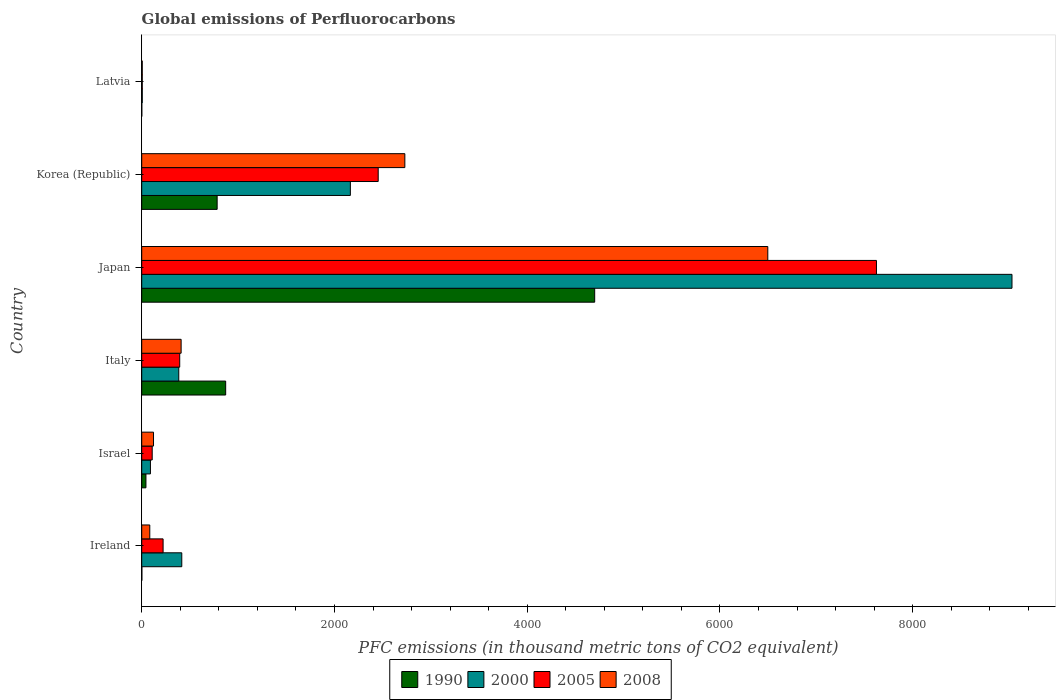How many different coloured bars are there?
Provide a succinct answer. 4. Are the number of bars on each tick of the Y-axis equal?
Make the answer very short. Yes. How many bars are there on the 2nd tick from the top?
Your response must be concise. 4. How many bars are there on the 4th tick from the bottom?
Offer a very short reply. 4. What is the label of the 3rd group of bars from the top?
Your response must be concise. Japan. What is the global emissions of Perfluorocarbons in 2005 in Italy?
Provide a succinct answer. 394.3. Across all countries, what is the maximum global emissions of Perfluorocarbons in 2008?
Give a very brief answer. 6496.1. In which country was the global emissions of Perfluorocarbons in 2005 maximum?
Give a very brief answer. Japan. In which country was the global emissions of Perfluorocarbons in 2000 minimum?
Provide a short and direct response. Latvia. What is the total global emissions of Perfluorocarbons in 2005 in the graph?
Offer a terse response. 1.08e+04. What is the difference between the global emissions of Perfluorocarbons in 2008 in Ireland and that in Korea (Republic)?
Ensure brevity in your answer.  -2646.5. What is the difference between the global emissions of Perfluorocarbons in 2000 in Italy and the global emissions of Perfluorocarbons in 2008 in Israel?
Offer a terse response. 262. What is the average global emissions of Perfluorocarbons in 2005 per country?
Keep it short and to the point. 1801.27. What is the ratio of the global emissions of Perfluorocarbons in 2008 in Ireland to that in Italy?
Provide a short and direct response. 0.2. Is the global emissions of Perfluorocarbons in 2005 in Ireland less than that in Israel?
Offer a very short reply. No. What is the difference between the highest and the second highest global emissions of Perfluorocarbons in 2008?
Offer a very short reply. 3766. What is the difference between the highest and the lowest global emissions of Perfluorocarbons in 2008?
Make the answer very short. 6490.6. Is the sum of the global emissions of Perfluorocarbons in 2008 in Israel and Korea (Republic) greater than the maximum global emissions of Perfluorocarbons in 2005 across all countries?
Your response must be concise. No. Is it the case that in every country, the sum of the global emissions of Perfluorocarbons in 2000 and global emissions of Perfluorocarbons in 2008 is greater than the sum of global emissions of Perfluorocarbons in 1990 and global emissions of Perfluorocarbons in 2005?
Make the answer very short. No. What does the 2nd bar from the top in Ireland represents?
Offer a very short reply. 2005. Is it the case that in every country, the sum of the global emissions of Perfluorocarbons in 2000 and global emissions of Perfluorocarbons in 2008 is greater than the global emissions of Perfluorocarbons in 2005?
Provide a succinct answer. Yes. What is the difference between two consecutive major ticks on the X-axis?
Provide a succinct answer. 2000. Are the values on the major ticks of X-axis written in scientific E-notation?
Your response must be concise. No. Does the graph contain grids?
Your response must be concise. No. How are the legend labels stacked?
Keep it short and to the point. Horizontal. What is the title of the graph?
Keep it short and to the point. Global emissions of Perfluorocarbons. What is the label or title of the X-axis?
Ensure brevity in your answer.  PFC emissions (in thousand metric tons of CO2 equivalent). What is the label or title of the Y-axis?
Give a very brief answer. Country. What is the PFC emissions (in thousand metric tons of CO2 equivalent) of 1990 in Ireland?
Provide a short and direct response. 1.4. What is the PFC emissions (in thousand metric tons of CO2 equivalent) in 2000 in Ireland?
Give a very brief answer. 415.6. What is the PFC emissions (in thousand metric tons of CO2 equivalent) of 2005 in Ireland?
Offer a very short reply. 221.8. What is the PFC emissions (in thousand metric tons of CO2 equivalent) in 2008 in Ireland?
Ensure brevity in your answer.  83.6. What is the PFC emissions (in thousand metric tons of CO2 equivalent) of 1990 in Israel?
Make the answer very short. 43.8. What is the PFC emissions (in thousand metric tons of CO2 equivalent) of 2000 in Israel?
Keep it short and to the point. 90.5. What is the PFC emissions (in thousand metric tons of CO2 equivalent) in 2005 in Israel?
Ensure brevity in your answer.  108.7. What is the PFC emissions (in thousand metric tons of CO2 equivalent) of 2008 in Israel?
Your answer should be compact. 122.3. What is the PFC emissions (in thousand metric tons of CO2 equivalent) in 1990 in Italy?
Your response must be concise. 871. What is the PFC emissions (in thousand metric tons of CO2 equivalent) in 2000 in Italy?
Keep it short and to the point. 384.3. What is the PFC emissions (in thousand metric tons of CO2 equivalent) of 2005 in Italy?
Ensure brevity in your answer.  394.3. What is the PFC emissions (in thousand metric tons of CO2 equivalent) of 2008 in Italy?
Your answer should be compact. 408.8. What is the PFC emissions (in thousand metric tons of CO2 equivalent) in 1990 in Japan?
Offer a very short reply. 4700. What is the PFC emissions (in thousand metric tons of CO2 equivalent) in 2000 in Japan?
Offer a terse response. 9029.8. What is the PFC emissions (in thousand metric tons of CO2 equivalent) in 2005 in Japan?
Provide a short and direct response. 7623.6. What is the PFC emissions (in thousand metric tons of CO2 equivalent) in 2008 in Japan?
Give a very brief answer. 6496.1. What is the PFC emissions (in thousand metric tons of CO2 equivalent) of 1990 in Korea (Republic)?
Provide a short and direct response. 782.6. What is the PFC emissions (in thousand metric tons of CO2 equivalent) in 2000 in Korea (Republic)?
Provide a short and direct response. 2164.9. What is the PFC emissions (in thousand metric tons of CO2 equivalent) of 2005 in Korea (Republic)?
Your answer should be compact. 2453.7. What is the PFC emissions (in thousand metric tons of CO2 equivalent) of 2008 in Korea (Republic)?
Your answer should be compact. 2730.1. What is the PFC emissions (in thousand metric tons of CO2 equivalent) of 2000 in Latvia?
Keep it short and to the point. 5.7. Across all countries, what is the maximum PFC emissions (in thousand metric tons of CO2 equivalent) of 1990?
Your answer should be very brief. 4700. Across all countries, what is the maximum PFC emissions (in thousand metric tons of CO2 equivalent) of 2000?
Your answer should be compact. 9029.8. Across all countries, what is the maximum PFC emissions (in thousand metric tons of CO2 equivalent) in 2005?
Provide a succinct answer. 7623.6. Across all countries, what is the maximum PFC emissions (in thousand metric tons of CO2 equivalent) in 2008?
Provide a short and direct response. 6496.1. Across all countries, what is the minimum PFC emissions (in thousand metric tons of CO2 equivalent) of 2005?
Your answer should be very brief. 5.5. What is the total PFC emissions (in thousand metric tons of CO2 equivalent) in 1990 in the graph?
Provide a succinct answer. 6399.5. What is the total PFC emissions (in thousand metric tons of CO2 equivalent) in 2000 in the graph?
Your response must be concise. 1.21e+04. What is the total PFC emissions (in thousand metric tons of CO2 equivalent) of 2005 in the graph?
Ensure brevity in your answer.  1.08e+04. What is the total PFC emissions (in thousand metric tons of CO2 equivalent) of 2008 in the graph?
Make the answer very short. 9846.4. What is the difference between the PFC emissions (in thousand metric tons of CO2 equivalent) in 1990 in Ireland and that in Israel?
Provide a short and direct response. -42.4. What is the difference between the PFC emissions (in thousand metric tons of CO2 equivalent) of 2000 in Ireland and that in Israel?
Your response must be concise. 325.1. What is the difference between the PFC emissions (in thousand metric tons of CO2 equivalent) of 2005 in Ireland and that in Israel?
Your response must be concise. 113.1. What is the difference between the PFC emissions (in thousand metric tons of CO2 equivalent) in 2008 in Ireland and that in Israel?
Your response must be concise. -38.7. What is the difference between the PFC emissions (in thousand metric tons of CO2 equivalent) in 1990 in Ireland and that in Italy?
Your answer should be compact. -869.6. What is the difference between the PFC emissions (in thousand metric tons of CO2 equivalent) of 2000 in Ireland and that in Italy?
Provide a short and direct response. 31.3. What is the difference between the PFC emissions (in thousand metric tons of CO2 equivalent) of 2005 in Ireland and that in Italy?
Your answer should be compact. -172.5. What is the difference between the PFC emissions (in thousand metric tons of CO2 equivalent) in 2008 in Ireland and that in Italy?
Provide a succinct answer. -325.2. What is the difference between the PFC emissions (in thousand metric tons of CO2 equivalent) of 1990 in Ireland and that in Japan?
Your answer should be compact. -4698.6. What is the difference between the PFC emissions (in thousand metric tons of CO2 equivalent) in 2000 in Ireland and that in Japan?
Offer a very short reply. -8614.2. What is the difference between the PFC emissions (in thousand metric tons of CO2 equivalent) in 2005 in Ireland and that in Japan?
Your response must be concise. -7401.8. What is the difference between the PFC emissions (in thousand metric tons of CO2 equivalent) in 2008 in Ireland and that in Japan?
Keep it short and to the point. -6412.5. What is the difference between the PFC emissions (in thousand metric tons of CO2 equivalent) in 1990 in Ireland and that in Korea (Republic)?
Give a very brief answer. -781.2. What is the difference between the PFC emissions (in thousand metric tons of CO2 equivalent) of 2000 in Ireland and that in Korea (Republic)?
Your answer should be compact. -1749.3. What is the difference between the PFC emissions (in thousand metric tons of CO2 equivalent) of 2005 in Ireland and that in Korea (Republic)?
Provide a short and direct response. -2231.9. What is the difference between the PFC emissions (in thousand metric tons of CO2 equivalent) in 2008 in Ireland and that in Korea (Republic)?
Provide a succinct answer. -2646.5. What is the difference between the PFC emissions (in thousand metric tons of CO2 equivalent) in 1990 in Ireland and that in Latvia?
Ensure brevity in your answer.  0.7. What is the difference between the PFC emissions (in thousand metric tons of CO2 equivalent) of 2000 in Ireland and that in Latvia?
Keep it short and to the point. 409.9. What is the difference between the PFC emissions (in thousand metric tons of CO2 equivalent) of 2005 in Ireland and that in Latvia?
Your answer should be compact. 216.3. What is the difference between the PFC emissions (in thousand metric tons of CO2 equivalent) of 2008 in Ireland and that in Latvia?
Give a very brief answer. 78.1. What is the difference between the PFC emissions (in thousand metric tons of CO2 equivalent) of 1990 in Israel and that in Italy?
Make the answer very short. -827.2. What is the difference between the PFC emissions (in thousand metric tons of CO2 equivalent) of 2000 in Israel and that in Italy?
Make the answer very short. -293.8. What is the difference between the PFC emissions (in thousand metric tons of CO2 equivalent) of 2005 in Israel and that in Italy?
Give a very brief answer. -285.6. What is the difference between the PFC emissions (in thousand metric tons of CO2 equivalent) of 2008 in Israel and that in Italy?
Offer a very short reply. -286.5. What is the difference between the PFC emissions (in thousand metric tons of CO2 equivalent) in 1990 in Israel and that in Japan?
Offer a very short reply. -4656.2. What is the difference between the PFC emissions (in thousand metric tons of CO2 equivalent) in 2000 in Israel and that in Japan?
Provide a short and direct response. -8939.3. What is the difference between the PFC emissions (in thousand metric tons of CO2 equivalent) of 2005 in Israel and that in Japan?
Your answer should be compact. -7514.9. What is the difference between the PFC emissions (in thousand metric tons of CO2 equivalent) in 2008 in Israel and that in Japan?
Provide a succinct answer. -6373.8. What is the difference between the PFC emissions (in thousand metric tons of CO2 equivalent) in 1990 in Israel and that in Korea (Republic)?
Your response must be concise. -738.8. What is the difference between the PFC emissions (in thousand metric tons of CO2 equivalent) of 2000 in Israel and that in Korea (Republic)?
Ensure brevity in your answer.  -2074.4. What is the difference between the PFC emissions (in thousand metric tons of CO2 equivalent) of 2005 in Israel and that in Korea (Republic)?
Offer a very short reply. -2345. What is the difference between the PFC emissions (in thousand metric tons of CO2 equivalent) in 2008 in Israel and that in Korea (Republic)?
Provide a succinct answer. -2607.8. What is the difference between the PFC emissions (in thousand metric tons of CO2 equivalent) in 1990 in Israel and that in Latvia?
Keep it short and to the point. 43.1. What is the difference between the PFC emissions (in thousand metric tons of CO2 equivalent) of 2000 in Israel and that in Latvia?
Your answer should be very brief. 84.8. What is the difference between the PFC emissions (in thousand metric tons of CO2 equivalent) of 2005 in Israel and that in Latvia?
Your answer should be very brief. 103.2. What is the difference between the PFC emissions (in thousand metric tons of CO2 equivalent) in 2008 in Israel and that in Latvia?
Make the answer very short. 116.8. What is the difference between the PFC emissions (in thousand metric tons of CO2 equivalent) in 1990 in Italy and that in Japan?
Give a very brief answer. -3829. What is the difference between the PFC emissions (in thousand metric tons of CO2 equivalent) in 2000 in Italy and that in Japan?
Your answer should be compact. -8645.5. What is the difference between the PFC emissions (in thousand metric tons of CO2 equivalent) in 2005 in Italy and that in Japan?
Provide a succinct answer. -7229.3. What is the difference between the PFC emissions (in thousand metric tons of CO2 equivalent) in 2008 in Italy and that in Japan?
Your response must be concise. -6087.3. What is the difference between the PFC emissions (in thousand metric tons of CO2 equivalent) of 1990 in Italy and that in Korea (Republic)?
Your response must be concise. 88.4. What is the difference between the PFC emissions (in thousand metric tons of CO2 equivalent) in 2000 in Italy and that in Korea (Republic)?
Ensure brevity in your answer.  -1780.6. What is the difference between the PFC emissions (in thousand metric tons of CO2 equivalent) in 2005 in Italy and that in Korea (Republic)?
Your answer should be compact. -2059.4. What is the difference between the PFC emissions (in thousand metric tons of CO2 equivalent) of 2008 in Italy and that in Korea (Republic)?
Give a very brief answer. -2321.3. What is the difference between the PFC emissions (in thousand metric tons of CO2 equivalent) of 1990 in Italy and that in Latvia?
Offer a terse response. 870.3. What is the difference between the PFC emissions (in thousand metric tons of CO2 equivalent) in 2000 in Italy and that in Latvia?
Provide a short and direct response. 378.6. What is the difference between the PFC emissions (in thousand metric tons of CO2 equivalent) in 2005 in Italy and that in Latvia?
Your answer should be compact. 388.8. What is the difference between the PFC emissions (in thousand metric tons of CO2 equivalent) of 2008 in Italy and that in Latvia?
Give a very brief answer. 403.3. What is the difference between the PFC emissions (in thousand metric tons of CO2 equivalent) of 1990 in Japan and that in Korea (Republic)?
Your response must be concise. 3917.4. What is the difference between the PFC emissions (in thousand metric tons of CO2 equivalent) in 2000 in Japan and that in Korea (Republic)?
Provide a succinct answer. 6864.9. What is the difference between the PFC emissions (in thousand metric tons of CO2 equivalent) in 2005 in Japan and that in Korea (Republic)?
Make the answer very short. 5169.9. What is the difference between the PFC emissions (in thousand metric tons of CO2 equivalent) of 2008 in Japan and that in Korea (Republic)?
Offer a terse response. 3766. What is the difference between the PFC emissions (in thousand metric tons of CO2 equivalent) in 1990 in Japan and that in Latvia?
Ensure brevity in your answer.  4699.3. What is the difference between the PFC emissions (in thousand metric tons of CO2 equivalent) in 2000 in Japan and that in Latvia?
Your answer should be very brief. 9024.1. What is the difference between the PFC emissions (in thousand metric tons of CO2 equivalent) of 2005 in Japan and that in Latvia?
Keep it short and to the point. 7618.1. What is the difference between the PFC emissions (in thousand metric tons of CO2 equivalent) in 2008 in Japan and that in Latvia?
Give a very brief answer. 6490.6. What is the difference between the PFC emissions (in thousand metric tons of CO2 equivalent) of 1990 in Korea (Republic) and that in Latvia?
Your response must be concise. 781.9. What is the difference between the PFC emissions (in thousand metric tons of CO2 equivalent) of 2000 in Korea (Republic) and that in Latvia?
Give a very brief answer. 2159.2. What is the difference between the PFC emissions (in thousand metric tons of CO2 equivalent) of 2005 in Korea (Republic) and that in Latvia?
Keep it short and to the point. 2448.2. What is the difference between the PFC emissions (in thousand metric tons of CO2 equivalent) of 2008 in Korea (Republic) and that in Latvia?
Offer a very short reply. 2724.6. What is the difference between the PFC emissions (in thousand metric tons of CO2 equivalent) of 1990 in Ireland and the PFC emissions (in thousand metric tons of CO2 equivalent) of 2000 in Israel?
Give a very brief answer. -89.1. What is the difference between the PFC emissions (in thousand metric tons of CO2 equivalent) in 1990 in Ireland and the PFC emissions (in thousand metric tons of CO2 equivalent) in 2005 in Israel?
Make the answer very short. -107.3. What is the difference between the PFC emissions (in thousand metric tons of CO2 equivalent) of 1990 in Ireland and the PFC emissions (in thousand metric tons of CO2 equivalent) of 2008 in Israel?
Offer a very short reply. -120.9. What is the difference between the PFC emissions (in thousand metric tons of CO2 equivalent) in 2000 in Ireland and the PFC emissions (in thousand metric tons of CO2 equivalent) in 2005 in Israel?
Your answer should be compact. 306.9. What is the difference between the PFC emissions (in thousand metric tons of CO2 equivalent) of 2000 in Ireland and the PFC emissions (in thousand metric tons of CO2 equivalent) of 2008 in Israel?
Your answer should be very brief. 293.3. What is the difference between the PFC emissions (in thousand metric tons of CO2 equivalent) in 2005 in Ireland and the PFC emissions (in thousand metric tons of CO2 equivalent) in 2008 in Israel?
Your answer should be compact. 99.5. What is the difference between the PFC emissions (in thousand metric tons of CO2 equivalent) of 1990 in Ireland and the PFC emissions (in thousand metric tons of CO2 equivalent) of 2000 in Italy?
Give a very brief answer. -382.9. What is the difference between the PFC emissions (in thousand metric tons of CO2 equivalent) in 1990 in Ireland and the PFC emissions (in thousand metric tons of CO2 equivalent) in 2005 in Italy?
Your answer should be very brief. -392.9. What is the difference between the PFC emissions (in thousand metric tons of CO2 equivalent) in 1990 in Ireland and the PFC emissions (in thousand metric tons of CO2 equivalent) in 2008 in Italy?
Give a very brief answer. -407.4. What is the difference between the PFC emissions (in thousand metric tons of CO2 equivalent) of 2000 in Ireland and the PFC emissions (in thousand metric tons of CO2 equivalent) of 2005 in Italy?
Provide a short and direct response. 21.3. What is the difference between the PFC emissions (in thousand metric tons of CO2 equivalent) in 2005 in Ireland and the PFC emissions (in thousand metric tons of CO2 equivalent) in 2008 in Italy?
Offer a terse response. -187. What is the difference between the PFC emissions (in thousand metric tons of CO2 equivalent) of 1990 in Ireland and the PFC emissions (in thousand metric tons of CO2 equivalent) of 2000 in Japan?
Provide a succinct answer. -9028.4. What is the difference between the PFC emissions (in thousand metric tons of CO2 equivalent) in 1990 in Ireland and the PFC emissions (in thousand metric tons of CO2 equivalent) in 2005 in Japan?
Your response must be concise. -7622.2. What is the difference between the PFC emissions (in thousand metric tons of CO2 equivalent) of 1990 in Ireland and the PFC emissions (in thousand metric tons of CO2 equivalent) of 2008 in Japan?
Make the answer very short. -6494.7. What is the difference between the PFC emissions (in thousand metric tons of CO2 equivalent) of 2000 in Ireland and the PFC emissions (in thousand metric tons of CO2 equivalent) of 2005 in Japan?
Give a very brief answer. -7208. What is the difference between the PFC emissions (in thousand metric tons of CO2 equivalent) of 2000 in Ireland and the PFC emissions (in thousand metric tons of CO2 equivalent) of 2008 in Japan?
Your answer should be very brief. -6080.5. What is the difference between the PFC emissions (in thousand metric tons of CO2 equivalent) in 2005 in Ireland and the PFC emissions (in thousand metric tons of CO2 equivalent) in 2008 in Japan?
Your response must be concise. -6274.3. What is the difference between the PFC emissions (in thousand metric tons of CO2 equivalent) in 1990 in Ireland and the PFC emissions (in thousand metric tons of CO2 equivalent) in 2000 in Korea (Republic)?
Your response must be concise. -2163.5. What is the difference between the PFC emissions (in thousand metric tons of CO2 equivalent) in 1990 in Ireland and the PFC emissions (in thousand metric tons of CO2 equivalent) in 2005 in Korea (Republic)?
Your answer should be very brief. -2452.3. What is the difference between the PFC emissions (in thousand metric tons of CO2 equivalent) of 1990 in Ireland and the PFC emissions (in thousand metric tons of CO2 equivalent) of 2008 in Korea (Republic)?
Your answer should be compact. -2728.7. What is the difference between the PFC emissions (in thousand metric tons of CO2 equivalent) in 2000 in Ireland and the PFC emissions (in thousand metric tons of CO2 equivalent) in 2005 in Korea (Republic)?
Ensure brevity in your answer.  -2038.1. What is the difference between the PFC emissions (in thousand metric tons of CO2 equivalent) of 2000 in Ireland and the PFC emissions (in thousand metric tons of CO2 equivalent) of 2008 in Korea (Republic)?
Provide a short and direct response. -2314.5. What is the difference between the PFC emissions (in thousand metric tons of CO2 equivalent) in 2005 in Ireland and the PFC emissions (in thousand metric tons of CO2 equivalent) in 2008 in Korea (Republic)?
Offer a terse response. -2508.3. What is the difference between the PFC emissions (in thousand metric tons of CO2 equivalent) of 1990 in Ireland and the PFC emissions (in thousand metric tons of CO2 equivalent) of 2000 in Latvia?
Offer a terse response. -4.3. What is the difference between the PFC emissions (in thousand metric tons of CO2 equivalent) of 1990 in Ireland and the PFC emissions (in thousand metric tons of CO2 equivalent) of 2005 in Latvia?
Your answer should be very brief. -4.1. What is the difference between the PFC emissions (in thousand metric tons of CO2 equivalent) in 1990 in Ireland and the PFC emissions (in thousand metric tons of CO2 equivalent) in 2008 in Latvia?
Your response must be concise. -4.1. What is the difference between the PFC emissions (in thousand metric tons of CO2 equivalent) of 2000 in Ireland and the PFC emissions (in thousand metric tons of CO2 equivalent) of 2005 in Latvia?
Your answer should be very brief. 410.1. What is the difference between the PFC emissions (in thousand metric tons of CO2 equivalent) in 2000 in Ireland and the PFC emissions (in thousand metric tons of CO2 equivalent) in 2008 in Latvia?
Offer a terse response. 410.1. What is the difference between the PFC emissions (in thousand metric tons of CO2 equivalent) in 2005 in Ireland and the PFC emissions (in thousand metric tons of CO2 equivalent) in 2008 in Latvia?
Provide a short and direct response. 216.3. What is the difference between the PFC emissions (in thousand metric tons of CO2 equivalent) of 1990 in Israel and the PFC emissions (in thousand metric tons of CO2 equivalent) of 2000 in Italy?
Ensure brevity in your answer.  -340.5. What is the difference between the PFC emissions (in thousand metric tons of CO2 equivalent) in 1990 in Israel and the PFC emissions (in thousand metric tons of CO2 equivalent) in 2005 in Italy?
Your answer should be very brief. -350.5. What is the difference between the PFC emissions (in thousand metric tons of CO2 equivalent) of 1990 in Israel and the PFC emissions (in thousand metric tons of CO2 equivalent) of 2008 in Italy?
Provide a succinct answer. -365. What is the difference between the PFC emissions (in thousand metric tons of CO2 equivalent) in 2000 in Israel and the PFC emissions (in thousand metric tons of CO2 equivalent) in 2005 in Italy?
Your answer should be compact. -303.8. What is the difference between the PFC emissions (in thousand metric tons of CO2 equivalent) of 2000 in Israel and the PFC emissions (in thousand metric tons of CO2 equivalent) of 2008 in Italy?
Make the answer very short. -318.3. What is the difference between the PFC emissions (in thousand metric tons of CO2 equivalent) of 2005 in Israel and the PFC emissions (in thousand metric tons of CO2 equivalent) of 2008 in Italy?
Offer a very short reply. -300.1. What is the difference between the PFC emissions (in thousand metric tons of CO2 equivalent) in 1990 in Israel and the PFC emissions (in thousand metric tons of CO2 equivalent) in 2000 in Japan?
Make the answer very short. -8986. What is the difference between the PFC emissions (in thousand metric tons of CO2 equivalent) in 1990 in Israel and the PFC emissions (in thousand metric tons of CO2 equivalent) in 2005 in Japan?
Offer a terse response. -7579.8. What is the difference between the PFC emissions (in thousand metric tons of CO2 equivalent) of 1990 in Israel and the PFC emissions (in thousand metric tons of CO2 equivalent) of 2008 in Japan?
Offer a terse response. -6452.3. What is the difference between the PFC emissions (in thousand metric tons of CO2 equivalent) of 2000 in Israel and the PFC emissions (in thousand metric tons of CO2 equivalent) of 2005 in Japan?
Your answer should be compact. -7533.1. What is the difference between the PFC emissions (in thousand metric tons of CO2 equivalent) in 2000 in Israel and the PFC emissions (in thousand metric tons of CO2 equivalent) in 2008 in Japan?
Offer a terse response. -6405.6. What is the difference between the PFC emissions (in thousand metric tons of CO2 equivalent) of 2005 in Israel and the PFC emissions (in thousand metric tons of CO2 equivalent) of 2008 in Japan?
Your response must be concise. -6387.4. What is the difference between the PFC emissions (in thousand metric tons of CO2 equivalent) of 1990 in Israel and the PFC emissions (in thousand metric tons of CO2 equivalent) of 2000 in Korea (Republic)?
Your response must be concise. -2121.1. What is the difference between the PFC emissions (in thousand metric tons of CO2 equivalent) of 1990 in Israel and the PFC emissions (in thousand metric tons of CO2 equivalent) of 2005 in Korea (Republic)?
Your answer should be compact. -2409.9. What is the difference between the PFC emissions (in thousand metric tons of CO2 equivalent) of 1990 in Israel and the PFC emissions (in thousand metric tons of CO2 equivalent) of 2008 in Korea (Republic)?
Provide a succinct answer. -2686.3. What is the difference between the PFC emissions (in thousand metric tons of CO2 equivalent) in 2000 in Israel and the PFC emissions (in thousand metric tons of CO2 equivalent) in 2005 in Korea (Republic)?
Keep it short and to the point. -2363.2. What is the difference between the PFC emissions (in thousand metric tons of CO2 equivalent) in 2000 in Israel and the PFC emissions (in thousand metric tons of CO2 equivalent) in 2008 in Korea (Republic)?
Offer a very short reply. -2639.6. What is the difference between the PFC emissions (in thousand metric tons of CO2 equivalent) of 2005 in Israel and the PFC emissions (in thousand metric tons of CO2 equivalent) of 2008 in Korea (Republic)?
Keep it short and to the point. -2621.4. What is the difference between the PFC emissions (in thousand metric tons of CO2 equivalent) in 1990 in Israel and the PFC emissions (in thousand metric tons of CO2 equivalent) in 2000 in Latvia?
Provide a succinct answer. 38.1. What is the difference between the PFC emissions (in thousand metric tons of CO2 equivalent) in 1990 in Israel and the PFC emissions (in thousand metric tons of CO2 equivalent) in 2005 in Latvia?
Give a very brief answer. 38.3. What is the difference between the PFC emissions (in thousand metric tons of CO2 equivalent) in 1990 in Israel and the PFC emissions (in thousand metric tons of CO2 equivalent) in 2008 in Latvia?
Keep it short and to the point. 38.3. What is the difference between the PFC emissions (in thousand metric tons of CO2 equivalent) of 2000 in Israel and the PFC emissions (in thousand metric tons of CO2 equivalent) of 2005 in Latvia?
Your answer should be compact. 85. What is the difference between the PFC emissions (in thousand metric tons of CO2 equivalent) in 2005 in Israel and the PFC emissions (in thousand metric tons of CO2 equivalent) in 2008 in Latvia?
Keep it short and to the point. 103.2. What is the difference between the PFC emissions (in thousand metric tons of CO2 equivalent) in 1990 in Italy and the PFC emissions (in thousand metric tons of CO2 equivalent) in 2000 in Japan?
Your response must be concise. -8158.8. What is the difference between the PFC emissions (in thousand metric tons of CO2 equivalent) in 1990 in Italy and the PFC emissions (in thousand metric tons of CO2 equivalent) in 2005 in Japan?
Make the answer very short. -6752.6. What is the difference between the PFC emissions (in thousand metric tons of CO2 equivalent) of 1990 in Italy and the PFC emissions (in thousand metric tons of CO2 equivalent) of 2008 in Japan?
Ensure brevity in your answer.  -5625.1. What is the difference between the PFC emissions (in thousand metric tons of CO2 equivalent) in 2000 in Italy and the PFC emissions (in thousand metric tons of CO2 equivalent) in 2005 in Japan?
Keep it short and to the point. -7239.3. What is the difference between the PFC emissions (in thousand metric tons of CO2 equivalent) of 2000 in Italy and the PFC emissions (in thousand metric tons of CO2 equivalent) of 2008 in Japan?
Your response must be concise. -6111.8. What is the difference between the PFC emissions (in thousand metric tons of CO2 equivalent) of 2005 in Italy and the PFC emissions (in thousand metric tons of CO2 equivalent) of 2008 in Japan?
Provide a succinct answer. -6101.8. What is the difference between the PFC emissions (in thousand metric tons of CO2 equivalent) of 1990 in Italy and the PFC emissions (in thousand metric tons of CO2 equivalent) of 2000 in Korea (Republic)?
Offer a very short reply. -1293.9. What is the difference between the PFC emissions (in thousand metric tons of CO2 equivalent) of 1990 in Italy and the PFC emissions (in thousand metric tons of CO2 equivalent) of 2005 in Korea (Republic)?
Provide a short and direct response. -1582.7. What is the difference between the PFC emissions (in thousand metric tons of CO2 equivalent) in 1990 in Italy and the PFC emissions (in thousand metric tons of CO2 equivalent) in 2008 in Korea (Republic)?
Offer a terse response. -1859.1. What is the difference between the PFC emissions (in thousand metric tons of CO2 equivalent) of 2000 in Italy and the PFC emissions (in thousand metric tons of CO2 equivalent) of 2005 in Korea (Republic)?
Your answer should be very brief. -2069.4. What is the difference between the PFC emissions (in thousand metric tons of CO2 equivalent) of 2000 in Italy and the PFC emissions (in thousand metric tons of CO2 equivalent) of 2008 in Korea (Republic)?
Give a very brief answer. -2345.8. What is the difference between the PFC emissions (in thousand metric tons of CO2 equivalent) in 2005 in Italy and the PFC emissions (in thousand metric tons of CO2 equivalent) in 2008 in Korea (Republic)?
Offer a terse response. -2335.8. What is the difference between the PFC emissions (in thousand metric tons of CO2 equivalent) of 1990 in Italy and the PFC emissions (in thousand metric tons of CO2 equivalent) of 2000 in Latvia?
Provide a succinct answer. 865.3. What is the difference between the PFC emissions (in thousand metric tons of CO2 equivalent) in 1990 in Italy and the PFC emissions (in thousand metric tons of CO2 equivalent) in 2005 in Latvia?
Provide a short and direct response. 865.5. What is the difference between the PFC emissions (in thousand metric tons of CO2 equivalent) in 1990 in Italy and the PFC emissions (in thousand metric tons of CO2 equivalent) in 2008 in Latvia?
Provide a succinct answer. 865.5. What is the difference between the PFC emissions (in thousand metric tons of CO2 equivalent) in 2000 in Italy and the PFC emissions (in thousand metric tons of CO2 equivalent) in 2005 in Latvia?
Keep it short and to the point. 378.8. What is the difference between the PFC emissions (in thousand metric tons of CO2 equivalent) in 2000 in Italy and the PFC emissions (in thousand metric tons of CO2 equivalent) in 2008 in Latvia?
Provide a succinct answer. 378.8. What is the difference between the PFC emissions (in thousand metric tons of CO2 equivalent) in 2005 in Italy and the PFC emissions (in thousand metric tons of CO2 equivalent) in 2008 in Latvia?
Your response must be concise. 388.8. What is the difference between the PFC emissions (in thousand metric tons of CO2 equivalent) of 1990 in Japan and the PFC emissions (in thousand metric tons of CO2 equivalent) of 2000 in Korea (Republic)?
Offer a very short reply. 2535.1. What is the difference between the PFC emissions (in thousand metric tons of CO2 equivalent) of 1990 in Japan and the PFC emissions (in thousand metric tons of CO2 equivalent) of 2005 in Korea (Republic)?
Give a very brief answer. 2246.3. What is the difference between the PFC emissions (in thousand metric tons of CO2 equivalent) in 1990 in Japan and the PFC emissions (in thousand metric tons of CO2 equivalent) in 2008 in Korea (Republic)?
Your answer should be very brief. 1969.9. What is the difference between the PFC emissions (in thousand metric tons of CO2 equivalent) of 2000 in Japan and the PFC emissions (in thousand metric tons of CO2 equivalent) of 2005 in Korea (Republic)?
Make the answer very short. 6576.1. What is the difference between the PFC emissions (in thousand metric tons of CO2 equivalent) in 2000 in Japan and the PFC emissions (in thousand metric tons of CO2 equivalent) in 2008 in Korea (Republic)?
Your answer should be compact. 6299.7. What is the difference between the PFC emissions (in thousand metric tons of CO2 equivalent) in 2005 in Japan and the PFC emissions (in thousand metric tons of CO2 equivalent) in 2008 in Korea (Republic)?
Provide a succinct answer. 4893.5. What is the difference between the PFC emissions (in thousand metric tons of CO2 equivalent) of 1990 in Japan and the PFC emissions (in thousand metric tons of CO2 equivalent) of 2000 in Latvia?
Ensure brevity in your answer.  4694.3. What is the difference between the PFC emissions (in thousand metric tons of CO2 equivalent) of 1990 in Japan and the PFC emissions (in thousand metric tons of CO2 equivalent) of 2005 in Latvia?
Give a very brief answer. 4694.5. What is the difference between the PFC emissions (in thousand metric tons of CO2 equivalent) of 1990 in Japan and the PFC emissions (in thousand metric tons of CO2 equivalent) of 2008 in Latvia?
Offer a terse response. 4694.5. What is the difference between the PFC emissions (in thousand metric tons of CO2 equivalent) of 2000 in Japan and the PFC emissions (in thousand metric tons of CO2 equivalent) of 2005 in Latvia?
Your answer should be very brief. 9024.3. What is the difference between the PFC emissions (in thousand metric tons of CO2 equivalent) in 2000 in Japan and the PFC emissions (in thousand metric tons of CO2 equivalent) in 2008 in Latvia?
Keep it short and to the point. 9024.3. What is the difference between the PFC emissions (in thousand metric tons of CO2 equivalent) in 2005 in Japan and the PFC emissions (in thousand metric tons of CO2 equivalent) in 2008 in Latvia?
Your answer should be very brief. 7618.1. What is the difference between the PFC emissions (in thousand metric tons of CO2 equivalent) of 1990 in Korea (Republic) and the PFC emissions (in thousand metric tons of CO2 equivalent) of 2000 in Latvia?
Your response must be concise. 776.9. What is the difference between the PFC emissions (in thousand metric tons of CO2 equivalent) in 1990 in Korea (Republic) and the PFC emissions (in thousand metric tons of CO2 equivalent) in 2005 in Latvia?
Provide a succinct answer. 777.1. What is the difference between the PFC emissions (in thousand metric tons of CO2 equivalent) of 1990 in Korea (Republic) and the PFC emissions (in thousand metric tons of CO2 equivalent) of 2008 in Latvia?
Your response must be concise. 777.1. What is the difference between the PFC emissions (in thousand metric tons of CO2 equivalent) in 2000 in Korea (Republic) and the PFC emissions (in thousand metric tons of CO2 equivalent) in 2005 in Latvia?
Make the answer very short. 2159.4. What is the difference between the PFC emissions (in thousand metric tons of CO2 equivalent) of 2000 in Korea (Republic) and the PFC emissions (in thousand metric tons of CO2 equivalent) of 2008 in Latvia?
Your response must be concise. 2159.4. What is the difference between the PFC emissions (in thousand metric tons of CO2 equivalent) of 2005 in Korea (Republic) and the PFC emissions (in thousand metric tons of CO2 equivalent) of 2008 in Latvia?
Your response must be concise. 2448.2. What is the average PFC emissions (in thousand metric tons of CO2 equivalent) of 1990 per country?
Your answer should be compact. 1066.58. What is the average PFC emissions (in thousand metric tons of CO2 equivalent) of 2000 per country?
Your answer should be very brief. 2015.13. What is the average PFC emissions (in thousand metric tons of CO2 equivalent) of 2005 per country?
Provide a succinct answer. 1801.27. What is the average PFC emissions (in thousand metric tons of CO2 equivalent) in 2008 per country?
Your answer should be very brief. 1641.07. What is the difference between the PFC emissions (in thousand metric tons of CO2 equivalent) in 1990 and PFC emissions (in thousand metric tons of CO2 equivalent) in 2000 in Ireland?
Give a very brief answer. -414.2. What is the difference between the PFC emissions (in thousand metric tons of CO2 equivalent) in 1990 and PFC emissions (in thousand metric tons of CO2 equivalent) in 2005 in Ireland?
Keep it short and to the point. -220.4. What is the difference between the PFC emissions (in thousand metric tons of CO2 equivalent) in 1990 and PFC emissions (in thousand metric tons of CO2 equivalent) in 2008 in Ireland?
Ensure brevity in your answer.  -82.2. What is the difference between the PFC emissions (in thousand metric tons of CO2 equivalent) in 2000 and PFC emissions (in thousand metric tons of CO2 equivalent) in 2005 in Ireland?
Offer a very short reply. 193.8. What is the difference between the PFC emissions (in thousand metric tons of CO2 equivalent) in 2000 and PFC emissions (in thousand metric tons of CO2 equivalent) in 2008 in Ireland?
Provide a short and direct response. 332. What is the difference between the PFC emissions (in thousand metric tons of CO2 equivalent) in 2005 and PFC emissions (in thousand metric tons of CO2 equivalent) in 2008 in Ireland?
Ensure brevity in your answer.  138.2. What is the difference between the PFC emissions (in thousand metric tons of CO2 equivalent) in 1990 and PFC emissions (in thousand metric tons of CO2 equivalent) in 2000 in Israel?
Offer a terse response. -46.7. What is the difference between the PFC emissions (in thousand metric tons of CO2 equivalent) of 1990 and PFC emissions (in thousand metric tons of CO2 equivalent) of 2005 in Israel?
Give a very brief answer. -64.9. What is the difference between the PFC emissions (in thousand metric tons of CO2 equivalent) in 1990 and PFC emissions (in thousand metric tons of CO2 equivalent) in 2008 in Israel?
Offer a very short reply. -78.5. What is the difference between the PFC emissions (in thousand metric tons of CO2 equivalent) of 2000 and PFC emissions (in thousand metric tons of CO2 equivalent) of 2005 in Israel?
Your response must be concise. -18.2. What is the difference between the PFC emissions (in thousand metric tons of CO2 equivalent) in 2000 and PFC emissions (in thousand metric tons of CO2 equivalent) in 2008 in Israel?
Keep it short and to the point. -31.8. What is the difference between the PFC emissions (in thousand metric tons of CO2 equivalent) in 2005 and PFC emissions (in thousand metric tons of CO2 equivalent) in 2008 in Israel?
Ensure brevity in your answer.  -13.6. What is the difference between the PFC emissions (in thousand metric tons of CO2 equivalent) of 1990 and PFC emissions (in thousand metric tons of CO2 equivalent) of 2000 in Italy?
Offer a very short reply. 486.7. What is the difference between the PFC emissions (in thousand metric tons of CO2 equivalent) of 1990 and PFC emissions (in thousand metric tons of CO2 equivalent) of 2005 in Italy?
Provide a succinct answer. 476.7. What is the difference between the PFC emissions (in thousand metric tons of CO2 equivalent) in 1990 and PFC emissions (in thousand metric tons of CO2 equivalent) in 2008 in Italy?
Offer a very short reply. 462.2. What is the difference between the PFC emissions (in thousand metric tons of CO2 equivalent) of 2000 and PFC emissions (in thousand metric tons of CO2 equivalent) of 2008 in Italy?
Keep it short and to the point. -24.5. What is the difference between the PFC emissions (in thousand metric tons of CO2 equivalent) of 1990 and PFC emissions (in thousand metric tons of CO2 equivalent) of 2000 in Japan?
Keep it short and to the point. -4329.8. What is the difference between the PFC emissions (in thousand metric tons of CO2 equivalent) in 1990 and PFC emissions (in thousand metric tons of CO2 equivalent) in 2005 in Japan?
Give a very brief answer. -2923.6. What is the difference between the PFC emissions (in thousand metric tons of CO2 equivalent) in 1990 and PFC emissions (in thousand metric tons of CO2 equivalent) in 2008 in Japan?
Offer a terse response. -1796.1. What is the difference between the PFC emissions (in thousand metric tons of CO2 equivalent) of 2000 and PFC emissions (in thousand metric tons of CO2 equivalent) of 2005 in Japan?
Make the answer very short. 1406.2. What is the difference between the PFC emissions (in thousand metric tons of CO2 equivalent) in 2000 and PFC emissions (in thousand metric tons of CO2 equivalent) in 2008 in Japan?
Ensure brevity in your answer.  2533.7. What is the difference between the PFC emissions (in thousand metric tons of CO2 equivalent) in 2005 and PFC emissions (in thousand metric tons of CO2 equivalent) in 2008 in Japan?
Provide a succinct answer. 1127.5. What is the difference between the PFC emissions (in thousand metric tons of CO2 equivalent) of 1990 and PFC emissions (in thousand metric tons of CO2 equivalent) of 2000 in Korea (Republic)?
Your response must be concise. -1382.3. What is the difference between the PFC emissions (in thousand metric tons of CO2 equivalent) of 1990 and PFC emissions (in thousand metric tons of CO2 equivalent) of 2005 in Korea (Republic)?
Keep it short and to the point. -1671.1. What is the difference between the PFC emissions (in thousand metric tons of CO2 equivalent) in 1990 and PFC emissions (in thousand metric tons of CO2 equivalent) in 2008 in Korea (Republic)?
Your answer should be very brief. -1947.5. What is the difference between the PFC emissions (in thousand metric tons of CO2 equivalent) of 2000 and PFC emissions (in thousand metric tons of CO2 equivalent) of 2005 in Korea (Republic)?
Your answer should be compact. -288.8. What is the difference between the PFC emissions (in thousand metric tons of CO2 equivalent) in 2000 and PFC emissions (in thousand metric tons of CO2 equivalent) in 2008 in Korea (Republic)?
Offer a terse response. -565.2. What is the difference between the PFC emissions (in thousand metric tons of CO2 equivalent) in 2005 and PFC emissions (in thousand metric tons of CO2 equivalent) in 2008 in Korea (Republic)?
Offer a terse response. -276.4. What is the difference between the PFC emissions (in thousand metric tons of CO2 equivalent) in 1990 and PFC emissions (in thousand metric tons of CO2 equivalent) in 2005 in Latvia?
Give a very brief answer. -4.8. What is the difference between the PFC emissions (in thousand metric tons of CO2 equivalent) of 1990 and PFC emissions (in thousand metric tons of CO2 equivalent) of 2008 in Latvia?
Provide a short and direct response. -4.8. What is the difference between the PFC emissions (in thousand metric tons of CO2 equivalent) in 2000 and PFC emissions (in thousand metric tons of CO2 equivalent) in 2008 in Latvia?
Provide a succinct answer. 0.2. What is the ratio of the PFC emissions (in thousand metric tons of CO2 equivalent) of 1990 in Ireland to that in Israel?
Your response must be concise. 0.03. What is the ratio of the PFC emissions (in thousand metric tons of CO2 equivalent) of 2000 in Ireland to that in Israel?
Keep it short and to the point. 4.59. What is the ratio of the PFC emissions (in thousand metric tons of CO2 equivalent) of 2005 in Ireland to that in Israel?
Your answer should be very brief. 2.04. What is the ratio of the PFC emissions (in thousand metric tons of CO2 equivalent) of 2008 in Ireland to that in Israel?
Keep it short and to the point. 0.68. What is the ratio of the PFC emissions (in thousand metric tons of CO2 equivalent) of 1990 in Ireland to that in Italy?
Your response must be concise. 0. What is the ratio of the PFC emissions (in thousand metric tons of CO2 equivalent) in 2000 in Ireland to that in Italy?
Your response must be concise. 1.08. What is the ratio of the PFC emissions (in thousand metric tons of CO2 equivalent) in 2005 in Ireland to that in Italy?
Your answer should be compact. 0.56. What is the ratio of the PFC emissions (in thousand metric tons of CO2 equivalent) in 2008 in Ireland to that in Italy?
Give a very brief answer. 0.2. What is the ratio of the PFC emissions (in thousand metric tons of CO2 equivalent) of 1990 in Ireland to that in Japan?
Provide a short and direct response. 0. What is the ratio of the PFC emissions (in thousand metric tons of CO2 equivalent) in 2000 in Ireland to that in Japan?
Your answer should be compact. 0.05. What is the ratio of the PFC emissions (in thousand metric tons of CO2 equivalent) of 2005 in Ireland to that in Japan?
Ensure brevity in your answer.  0.03. What is the ratio of the PFC emissions (in thousand metric tons of CO2 equivalent) in 2008 in Ireland to that in Japan?
Give a very brief answer. 0.01. What is the ratio of the PFC emissions (in thousand metric tons of CO2 equivalent) in 1990 in Ireland to that in Korea (Republic)?
Give a very brief answer. 0. What is the ratio of the PFC emissions (in thousand metric tons of CO2 equivalent) in 2000 in Ireland to that in Korea (Republic)?
Keep it short and to the point. 0.19. What is the ratio of the PFC emissions (in thousand metric tons of CO2 equivalent) in 2005 in Ireland to that in Korea (Republic)?
Your answer should be compact. 0.09. What is the ratio of the PFC emissions (in thousand metric tons of CO2 equivalent) in 2008 in Ireland to that in Korea (Republic)?
Your response must be concise. 0.03. What is the ratio of the PFC emissions (in thousand metric tons of CO2 equivalent) in 1990 in Ireland to that in Latvia?
Your answer should be compact. 2. What is the ratio of the PFC emissions (in thousand metric tons of CO2 equivalent) of 2000 in Ireland to that in Latvia?
Make the answer very short. 72.91. What is the ratio of the PFC emissions (in thousand metric tons of CO2 equivalent) of 2005 in Ireland to that in Latvia?
Make the answer very short. 40.33. What is the ratio of the PFC emissions (in thousand metric tons of CO2 equivalent) in 2008 in Ireland to that in Latvia?
Your response must be concise. 15.2. What is the ratio of the PFC emissions (in thousand metric tons of CO2 equivalent) of 1990 in Israel to that in Italy?
Provide a short and direct response. 0.05. What is the ratio of the PFC emissions (in thousand metric tons of CO2 equivalent) of 2000 in Israel to that in Italy?
Give a very brief answer. 0.24. What is the ratio of the PFC emissions (in thousand metric tons of CO2 equivalent) in 2005 in Israel to that in Italy?
Ensure brevity in your answer.  0.28. What is the ratio of the PFC emissions (in thousand metric tons of CO2 equivalent) in 2008 in Israel to that in Italy?
Give a very brief answer. 0.3. What is the ratio of the PFC emissions (in thousand metric tons of CO2 equivalent) of 1990 in Israel to that in Japan?
Provide a short and direct response. 0.01. What is the ratio of the PFC emissions (in thousand metric tons of CO2 equivalent) in 2000 in Israel to that in Japan?
Make the answer very short. 0.01. What is the ratio of the PFC emissions (in thousand metric tons of CO2 equivalent) in 2005 in Israel to that in Japan?
Provide a short and direct response. 0.01. What is the ratio of the PFC emissions (in thousand metric tons of CO2 equivalent) of 2008 in Israel to that in Japan?
Give a very brief answer. 0.02. What is the ratio of the PFC emissions (in thousand metric tons of CO2 equivalent) in 1990 in Israel to that in Korea (Republic)?
Your answer should be compact. 0.06. What is the ratio of the PFC emissions (in thousand metric tons of CO2 equivalent) of 2000 in Israel to that in Korea (Republic)?
Your answer should be very brief. 0.04. What is the ratio of the PFC emissions (in thousand metric tons of CO2 equivalent) in 2005 in Israel to that in Korea (Republic)?
Your answer should be very brief. 0.04. What is the ratio of the PFC emissions (in thousand metric tons of CO2 equivalent) in 2008 in Israel to that in Korea (Republic)?
Give a very brief answer. 0.04. What is the ratio of the PFC emissions (in thousand metric tons of CO2 equivalent) of 1990 in Israel to that in Latvia?
Keep it short and to the point. 62.57. What is the ratio of the PFC emissions (in thousand metric tons of CO2 equivalent) of 2000 in Israel to that in Latvia?
Your answer should be very brief. 15.88. What is the ratio of the PFC emissions (in thousand metric tons of CO2 equivalent) of 2005 in Israel to that in Latvia?
Make the answer very short. 19.76. What is the ratio of the PFC emissions (in thousand metric tons of CO2 equivalent) in 2008 in Israel to that in Latvia?
Your answer should be compact. 22.24. What is the ratio of the PFC emissions (in thousand metric tons of CO2 equivalent) of 1990 in Italy to that in Japan?
Make the answer very short. 0.19. What is the ratio of the PFC emissions (in thousand metric tons of CO2 equivalent) in 2000 in Italy to that in Japan?
Provide a succinct answer. 0.04. What is the ratio of the PFC emissions (in thousand metric tons of CO2 equivalent) in 2005 in Italy to that in Japan?
Keep it short and to the point. 0.05. What is the ratio of the PFC emissions (in thousand metric tons of CO2 equivalent) in 2008 in Italy to that in Japan?
Offer a terse response. 0.06. What is the ratio of the PFC emissions (in thousand metric tons of CO2 equivalent) in 1990 in Italy to that in Korea (Republic)?
Provide a succinct answer. 1.11. What is the ratio of the PFC emissions (in thousand metric tons of CO2 equivalent) of 2000 in Italy to that in Korea (Republic)?
Provide a succinct answer. 0.18. What is the ratio of the PFC emissions (in thousand metric tons of CO2 equivalent) of 2005 in Italy to that in Korea (Republic)?
Offer a terse response. 0.16. What is the ratio of the PFC emissions (in thousand metric tons of CO2 equivalent) in 2008 in Italy to that in Korea (Republic)?
Your answer should be compact. 0.15. What is the ratio of the PFC emissions (in thousand metric tons of CO2 equivalent) of 1990 in Italy to that in Latvia?
Ensure brevity in your answer.  1244.29. What is the ratio of the PFC emissions (in thousand metric tons of CO2 equivalent) in 2000 in Italy to that in Latvia?
Ensure brevity in your answer.  67.42. What is the ratio of the PFC emissions (in thousand metric tons of CO2 equivalent) in 2005 in Italy to that in Latvia?
Give a very brief answer. 71.69. What is the ratio of the PFC emissions (in thousand metric tons of CO2 equivalent) of 2008 in Italy to that in Latvia?
Your answer should be very brief. 74.33. What is the ratio of the PFC emissions (in thousand metric tons of CO2 equivalent) of 1990 in Japan to that in Korea (Republic)?
Provide a short and direct response. 6.01. What is the ratio of the PFC emissions (in thousand metric tons of CO2 equivalent) in 2000 in Japan to that in Korea (Republic)?
Give a very brief answer. 4.17. What is the ratio of the PFC emissions (in thousand metric tons of CO2 equivalent) in 2005 in Japan to that in Korea (Republic)?
Offer a very short reply. 3.11. What is the ratio of the PFC emissions (in thousand metric tons of CO2 equivalent) in 2008 in Japan to that in Korea (Republic)?
Ensure brevity in your answer.  2.38. What is the ratio of the PFC emissions (in thousand metric tons of CO2 equivalent) in 1990 in Japan to that in Latvia?
Give a very brief answer. 6714.29. What is the ratio of the PFC emissions (in thousand metric tons of CO2 equivalent) of 2000 in Japan to that in Latvia?
Offer a very short reply. 1584.18. What is the ratio of the PFC emissions (in thousand metric tons of CO2 equivalent) of 2005 in Japan to that in Latvia?
Make the answer very short. 1386.11. What is the ratio of the PFC emissions (in thousand metric tons of CO2 equivalent) of 2008 in Japan to that in Latvia?
Give a very brief answer. 1181.11. What is the ratio of the PFC emissions (in thousand metric tons of CO2 equivalent) of 1990 in Korea (Republic) to that in Latvia?
Offer a very short reply. 1118. What is the ratio of the PFC emissions (in thousand metric tons of CO2 equivalent) in 2000 in Korea (Republic) to that in Latvia?
Provide a succinct answer. 379.81. What is the ratio of the PFC emissions (in thousand metric tons of CO2 equivalent) in 2005 in Korea (Republic) to that in Latvia?
Offer a very short reply. 446.13. What is the ratio of the PFC emissions (in thousand metric tons of CO2 equivalent) in 2008 in Korea (Republic) to that in Latvia?
Your response must be concise. 496.38. What is the difference between the highest and the second highest PFC emissions (in thousand metric tons of CO2 equivalent) in 1990?
Offer a terse response. 3829. What is the difference between the highest and the second highest PFC emissions (in thousand metric tons of CO2 equivalent) of 2000?
Your answer should be compact. 6864.9. What is the difference between the highest and the second highest PFC emissions (in thousand metric tons of CO2 equivalent) of 2005?
Provide a short and direct response. 5169.9. What is the difference between the highest and the second highest PFC emissions (in thousand metric tons of CO2 equivalent) of 2008?
Your answer should be compact. 3766. What is the difference between the highest and the lowest PFC emissions (in thousand metric tons of CO2 equivalent) of 1990?
Provide a short and direct response. 4699.3. What is the difference between the highest and the lowest PFC emissions (in thousand metric tons of CO2 equivalent) of 2000?
Ensure brevity in your answer.  9024.1. What is the difference between the highest and the lowest PFC emissions (in thousand metric tons of CO2 equivalent) of 2005?
Your answer should be compact. 7618.1. What is the difference between the highest and the lowest PFC emissions (in thousand metric tons of CO2 equivalent) of 2008?
Offer a terse response. 6490.6. 